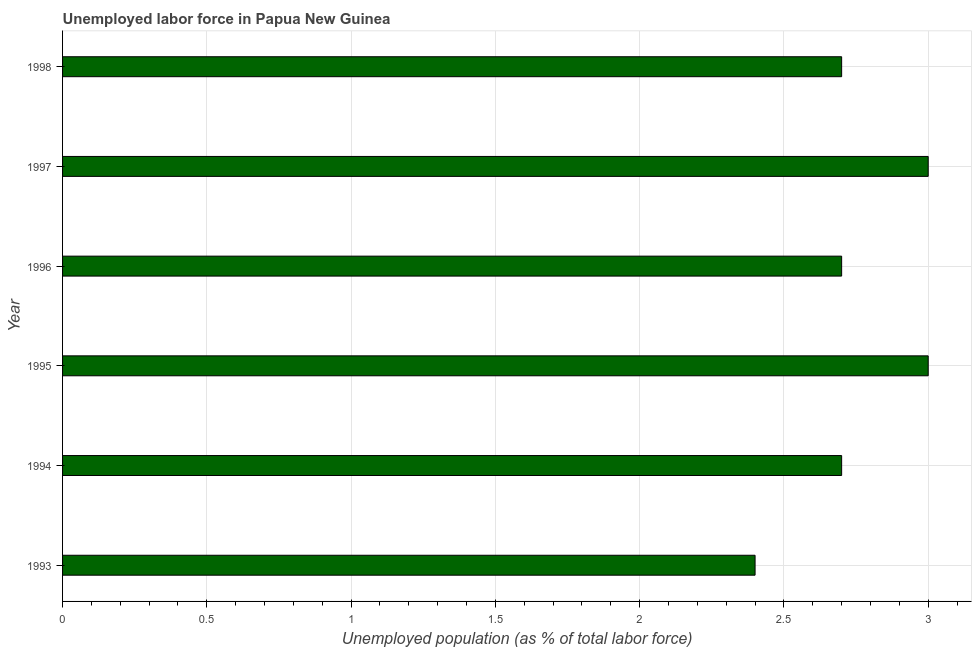Does the graph contain any zero values?
Your response must be concise. No. What is the title of the graph?
Make the answer very short. Unemployed labor force in Papua New Guinea. What is the label or title of the X-axis?
Ensure brevity in your answer.  Unemployed population (as % of total labor force). What is the total unemployed population in 1993?
Provide a succinct answer. 2.4. Across all years, what is the maximum total unemployed population?
Your response must be concise. 3. Across all years, what is the minimum total unemployed population?
Provide a short and direct response. 2.4. In which year was the total unemployed population maximum?
Offer a very short reply. 1995. What is the sum of the total unemployed population?
Provide a succinct answer. 16.5. What is the average total unemployed population per year?
Ensure brevity in your answer.  2.75. What is the median total unemployed population?
Offer a very short reply. 2.7. In how many years, is the total unemployed population greater than 1.7 %?
Your answer should be compact. 6. What is the ratio of the total unemployed population in 1993 to that in 1994?
Your response must be concise. 0.89. Is the total unemployed population in 1995 less than that in 1996?
Keep it short and to the point. No. What is the difference between the highest and the second highest total unemployed population?
Your answer should be very brief. 0. In how many years, is the total unemployed population greater than the average total unemployed population taken over all years?
Ensure brevity in your answer.  2. How many years are there in the graph?
Your answer should be compact. 6. Are the values on the major ticks of X-axis written in scientific E-notation?
Your answer should be compact. No. What is the Unemployed population (as % of total labor force) of 1993?
Provide a short and direct response. 2.4. What is the Unemployed population (as % of total labor force) of 1994?
Offer a terse response. 2.7. What is the Unemployed population (as % of total labor force) in 1996?
Keep it short and to the point. 2.7. What is the Unemployed population (as % of total labor force) of 1997?
Provide a short and direct response. 3. What is the Unemployed population (as % of total labor force) of 1998?
Your response must be concise. 2.7. What is the difference between the Unemployed population (as % of total labor force) in 1993 and 1995?
Provide a short and direct response. -0.6. What is the difference between the Unemployed population (as % of total labor force) in 1993 and 1996?
Ensure brevity in your answer.  -0.3. What is the difference between the Unemployed population (as % of total labor force) in 1993 and 1997?
Ensure brevity in your answer.  -0.6. What is the difference between the Unemployed population (as % of total labor force) in 1993 and 1998?
Your answer should be compact. -0.3. What is the difference between the Unemployed population (as % of total labor force) in 1994 and 1995?
Keep it short and to the point. -0.3. What is the difference between the Unemployed population (as % of total labor force) in 1994 and 1997?
Keep it short and to the point. -0.3. What is the difference between the Unemployed population (as % of total labor force) in 1995 and 1997?
Provide a short and direct response. 0. What is the ratio of the Unemployed population (as % of total labor force) in 1993 to that in 1994?
Offer a very short reply. 0.89. What is the ratio of the Unemployed population (as % of total labor force) in 1993 to that in 1996?
Give a very brief answer. 0.89. What is the ratio of the Unemployed population (as % of total labor force) in 1993 to that in 1998?
Offer a terse response. 0.89. What is the ratio of the Unemployed population (as % of total labor force) in 1994 to that in 1995?
Provide a short and direct response. 0.9. What is the ratio of the Unemployed population (as % of total labor force) in 1994 to that in 1996?
Provide a succinct answer. 1. What is the ratio of the Unemployed population (as % of total labor force) in 1994 to that in 1997?
Keep it short and to the point. 0.9. What is the ratio of the Unemployed population (as % of total labor force) in 1994 to that in 1998?
Make the answer very short. 1. What is the ratio of the Unemployed population (as % of total labor force) in 1995 to that in 1996?
Ensure brevity in your answer.  1.11. What is the ratio of the Unemployed population (as % of total labor force) in 1995 to that in 1997?
Your response must be concise. 1. What is the ratio of the Unemployed population (as % of total labor force) in 1995 to that in 1998?
Ensure brevity in your answer.  1.11. What is the ratio of the Unemployed population (as % of total labor force) in 1997 to that in 1998?
Ensure brevity in your answer.  1.11. 